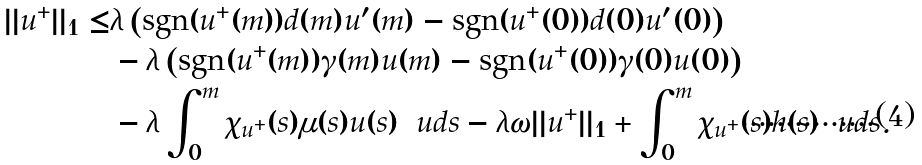<formula> <loc_0><loc_0><loc_500><loc_500>| | u ^ { + } | | _ { 1 } \leq & \lambda \left ( \text {sgn} ( u ^ { + } ( m ) ) d ( m ) u ^ { \prime } ( m ) - \text {sgn} ( u ^ { + } ( 0 ) ) d ( 0 ) u ^ { \prime } ( 0 ) \right ) \\ & - \lambda \left ( \text {sgn} ( u ^ { + } ( m ) ) \gamma ( m ) u ( m ) - \text {sgn} ( u ^ { + } ( 0 ) ) \gamma ( 0 ) u ( 0 ) \right ) \\ & - \lambda \int _ { 0 } ^ { m } \chi _ { u ^ { + } } ( s ) \mu ( s ) u ( s ) \, \ u d s - \lambda \omega | | u ^ { + } | | _ { 1 } + \int _ { 0 } ^ { m } \chi _ { u ^ { + } } ( s ) h ( s ) \, \ u d s .</formula> 